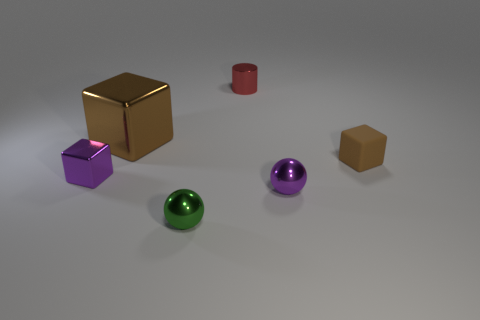Is there any other thing that has the same material as the tiny brown thing?
Your response must be concise. No. Is there anything else that has the same size as the brown metallic object?
Make the answer very short. No. Is the color of the thing right of the purple metal ball the same as the big object?
Keep it short and to the point. Yes. What number of balls are behind the tiny red cylinder?
Provide a short and direct response. 0. Is the number of red shiny cylinders greater than the number of tiny cyan rubber blocks?
Ensure brevity in your answer.  Yes. The metallic object that is both in front of the tiny brown matte thing and to the left of the small green shiny sphere has what shape?
Keep it short and to the point. Cube. Are there any purple shiny cubes?
Provide a succinct answer. Yes. What is the material of the other large object that is the same shape as the brown rubber thing?
Give a very brief answer. Metal. The tiny metal object that is behind the object that is right of the purple thing that is in front of the small purple cube is what shape?
Make the answer very short. Cylinder. There is a tiny sphere that is the same color as the tiny metallic cube; what material is it?
Ensure brevity in your answer.  Metal. 